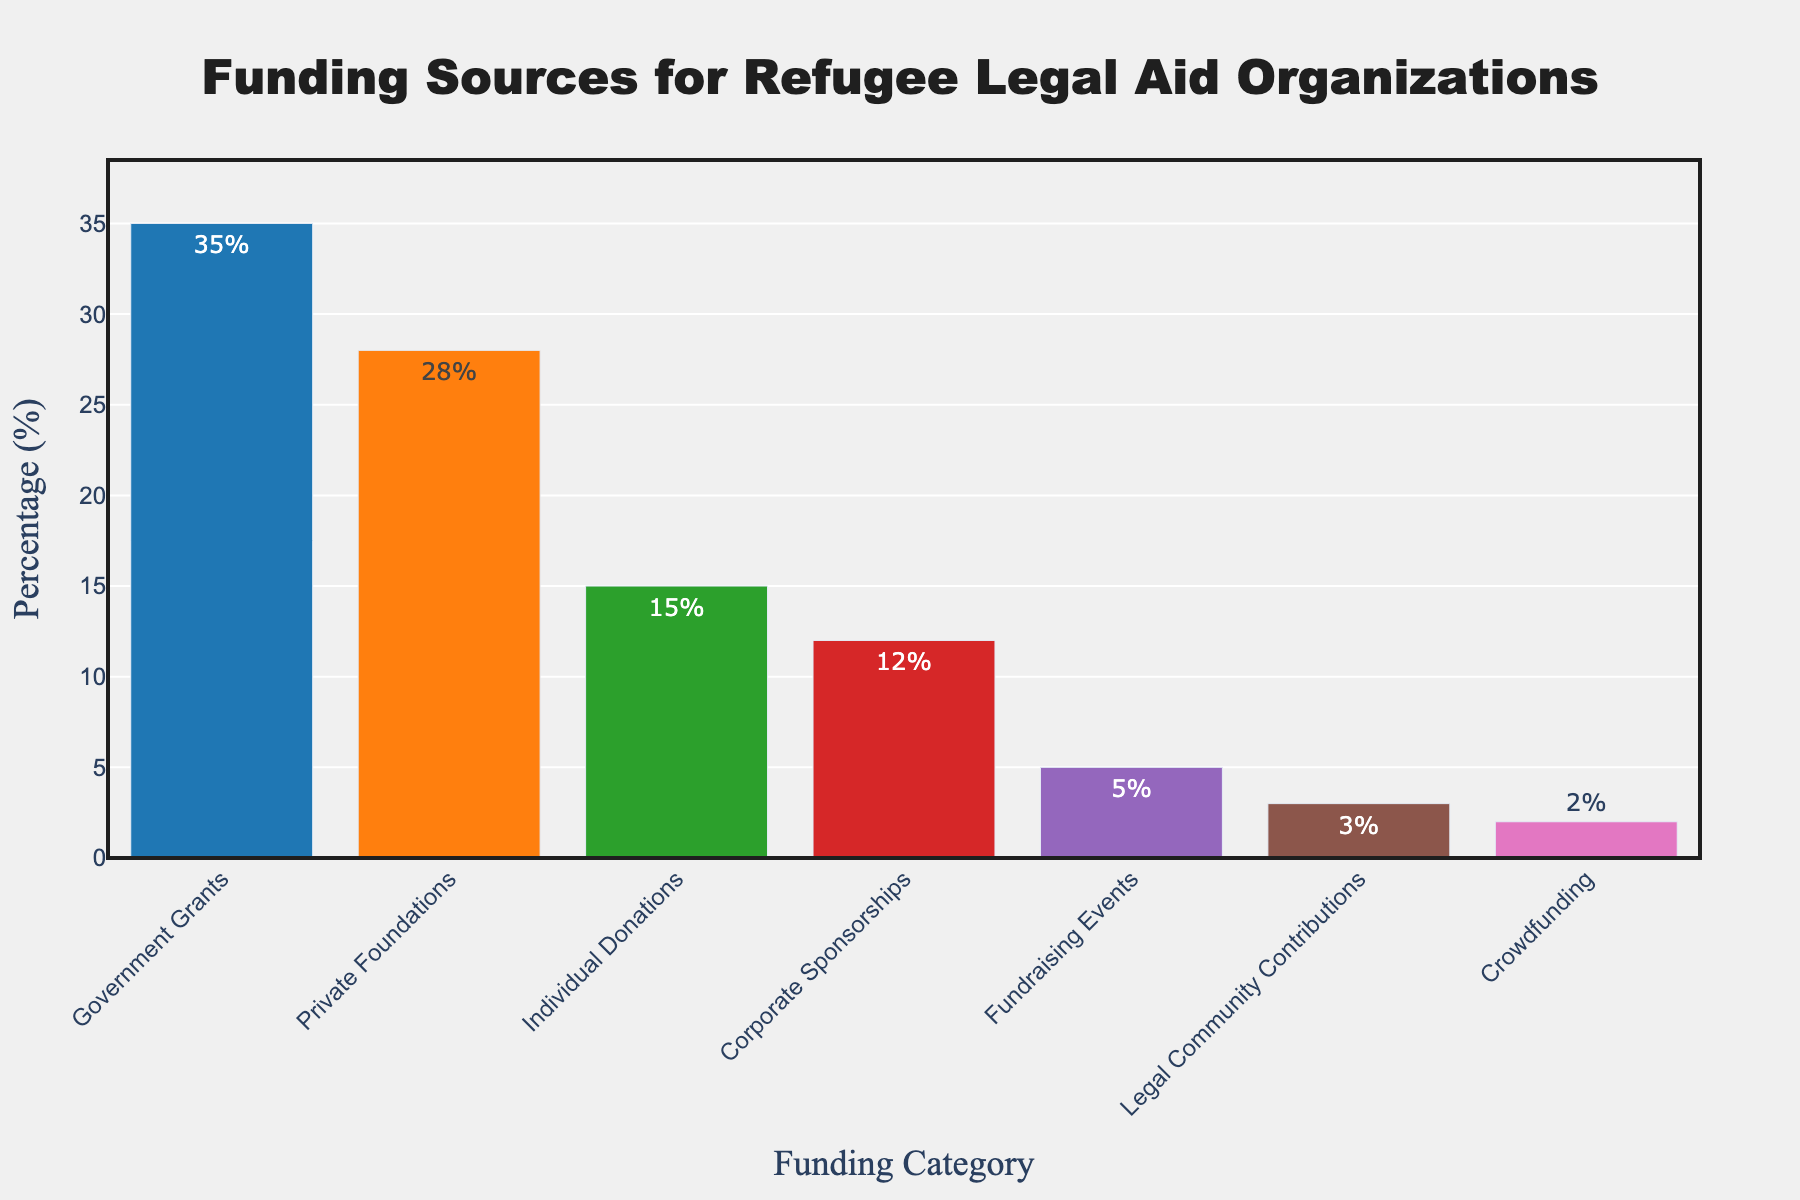What's the funding source with the highest percentage? The bar with the highest percentage represents Government Grants, which stands at 35%.
Answer: Government Grants Which funding source has the lowest percentage? The shortest bar in the chart represents Crowdfunding, with a percentage of 2%.
Answer: Crowdfunding How much more do Private Foundations contribute compared to Crowdfunding? The percentage for Private Foundations is 28% and for Crowdfunding is 2%. Subtracting these values gives 28% - 2% = 26%.
Answer: 26% Are Government Grants and Private Foundations together contributing more than 50%? Summing the percentages of Government Grants (35%) and Private Foundations (28%) results in 35% + 28% = 63%. Since 63% is more than 50%, the answer is yes.
Answer: Yes What is the combined percentage of Individual Donations and Corporate Sponsorships? The percentage for Individual Donations is 15% and for Corporate Sponsorships is 12%. Adding these values gives 15% + 12% = 27%.
Answer: 27% Which funding sources contribute more than 10%? The bars representing Government Grants (35%), Private Foundations (28%), Individual Donations (15%), and Corporate Sponsorships (12%) all exceed 10%.
Answer: Government Grants, Private Foundations, Individual Donations, Corporate Sponsorships Are there more funding sources that contribute less than 10% or more than 10%? There are four funding sources that contribute more than 10%: Government Grants, Private Foundations, Individual Donations, and Corporate Sponsorships. Three funding sources contribute less than 10%: Fundraising Events, Legal Community Contributions, and Crowdfunding.
Answer: More than 10% What is the median value of the funding sources? Ordering the percentages: 2%, 3%, 5%, 12%, 15%, 28%, 35%. The median value, being the fourth value in this sequence, is 12%.
Answer: 12% What percentage do Fundraising Events and Legal Community Contributions contribute together? Adding the percentage of Fundraising Events (5%) and Legal Community Contributions (3%) results in 5% + 3% = 8%.
Answer: 8% How does the percentage of Corporate Sponsorships compare to Fundraising Events and Legal Community Contributions combined? Corporate Sponsorships contribute 12%. Fundraising Events and Legal Community Contributions combined contribute 5% + 3% = 8%, which is less than 12%.
Answer: Greater 